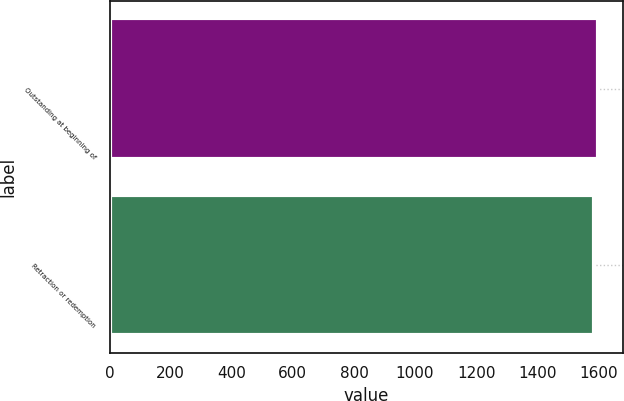Convert chart. <chart><loc_0><loc_0><loc_500><loc_500><bar_chart><fcel>Outstanding at beginning of<fcel>Retraction or redemption<nl><fcel>1600<fcel>1585<nl></chart> 